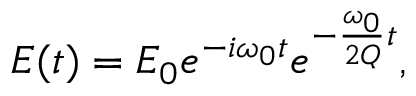<formula> <loc_0><loc_0><loc_500><loc_500>E ( t ) = E _ { 0 } e ^ { - i \omega _ { 0 } t } e ^ { - \frac { \omega _ { 0 } } { 2 Q } t } ,</formula> 